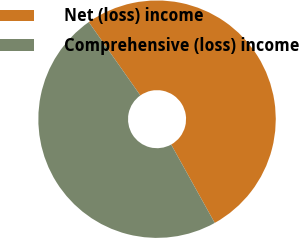Convert chart to OTSL. <chart><loc_0><loc_0><loc_500><loc_500><pie_chart><fcel>Net (loss) income<fcel>Comprehensive (loss) income<nl><fcel>51.68%<fcel>48.32%<nl></chart> 